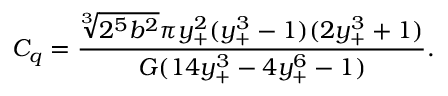<formula> <loc_0><loc_0><loc_500><loc_500>C _ { q } = \frac { \sqrt { [ } 3 ] { 2 ^ { 5 } b ^ { 2 } } \pi y _ { + } ^ { 2 } ( y _ { + } ^ { 3 } - 1 ) ( 2 y _ { + } ^ { 3 } + 1 ) } { G ( 1 4 y _ { + } ^ { 3 } - 4 y _ { + } ^ { 6 } - 1 ) } .</formula> 